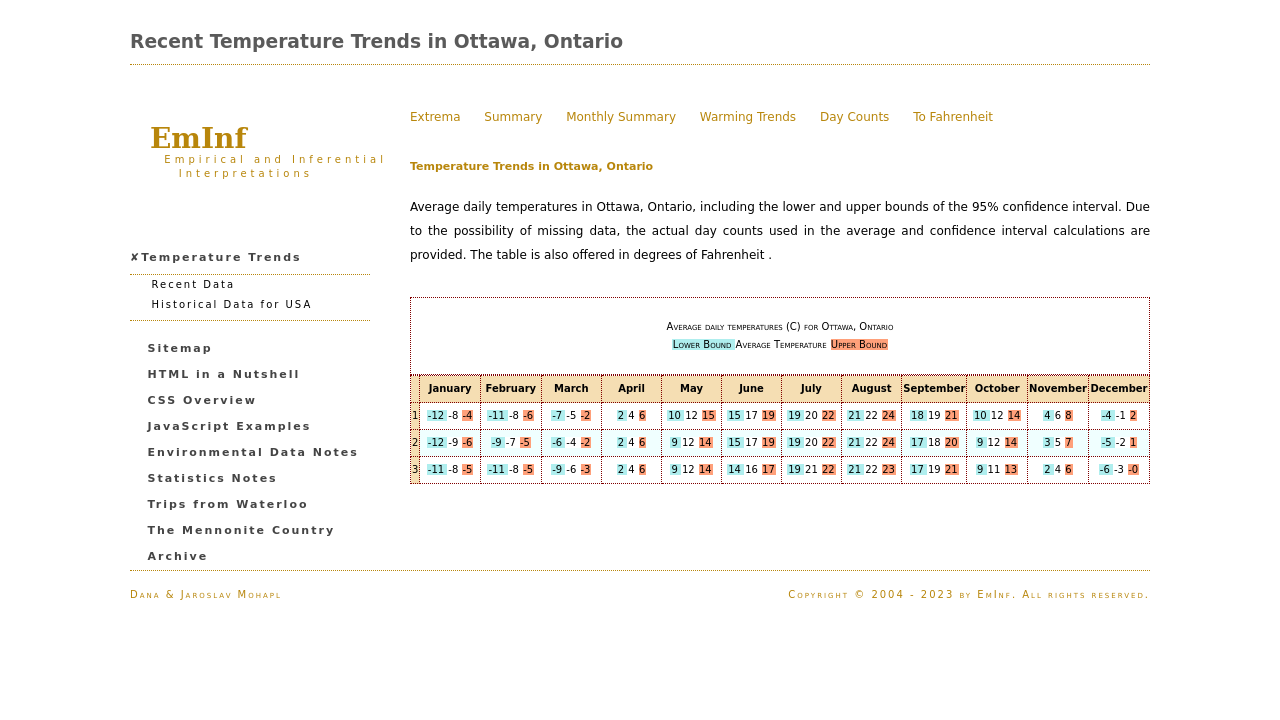Can you explain the significance of the color coding in the temperature chart? The color coding in the chart represents different temperature ranges. The blue color symbolizes the lower bound of the temperature, the white denotes the average temperature, and the red indicates the upper bound of the temperature ranges. This visual distinction helps in quickly understanding the variations in temperatures across months. 